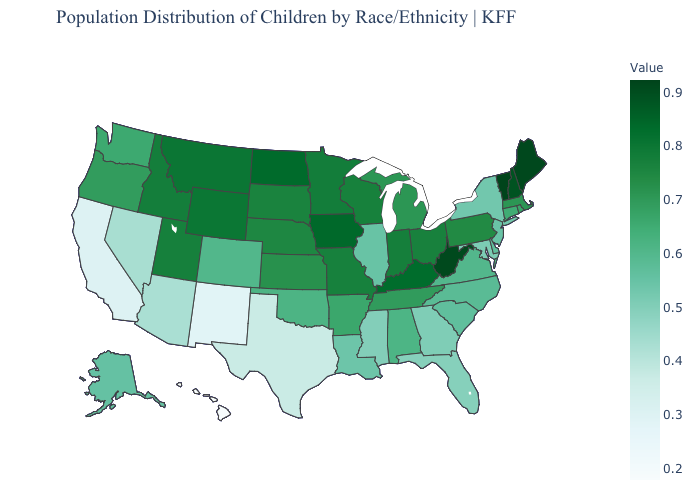Is the legend a continuous bar?
Keep it brief. Yes. Which states have the highest value in the USA?
Quick response, please. Vermont. Which states hav the highest value in the South?
Concise answer only. West Virginia. Does Iowa have the highest value in the MidWest?
Quick response, please. Yes. Among the states that border Idaho , does Nevada have the highest value?
Keep it brief. No. 